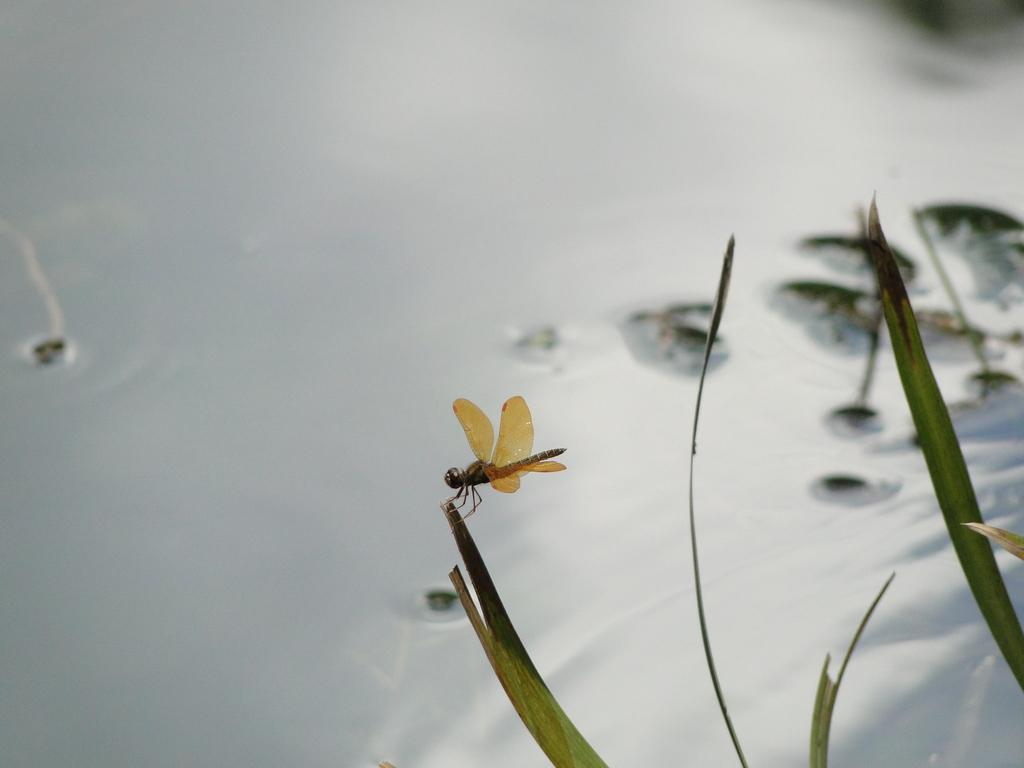What can be seen on the right side of the image? There are leaves visible on the right side of the image. Is there anything else on the leaves? Yes, there is a Dragonfly on one of the leaves. What might be the background of the image? The background might be water. What type of design can be seen on the leaves in the image? There is no specific design mentioned on the leaves in the provided facts, so we cannot answer this question. How many trees are visible in the image? The provided facts do not mention any trees, so we cannot answer this question. 